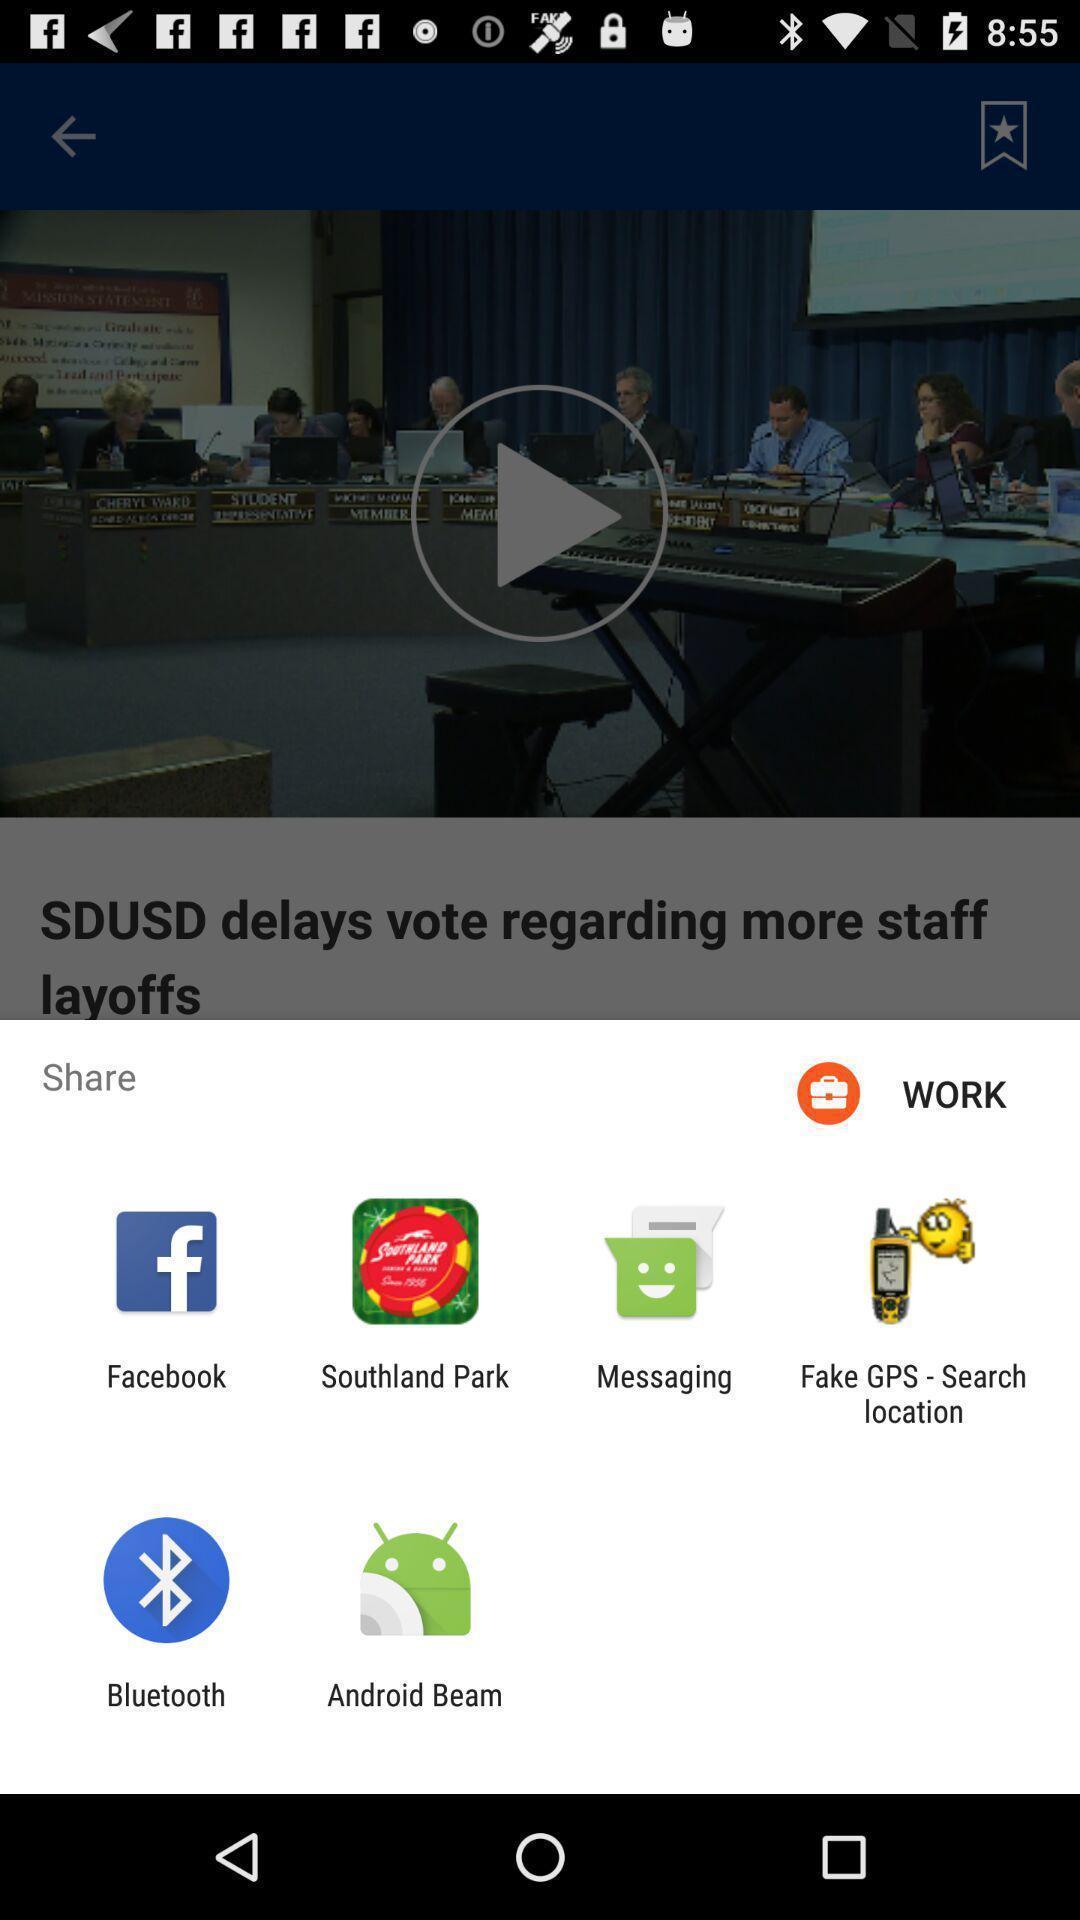Explain the elements present in this screenshot. Pop-up shows share option with multiple applications. 